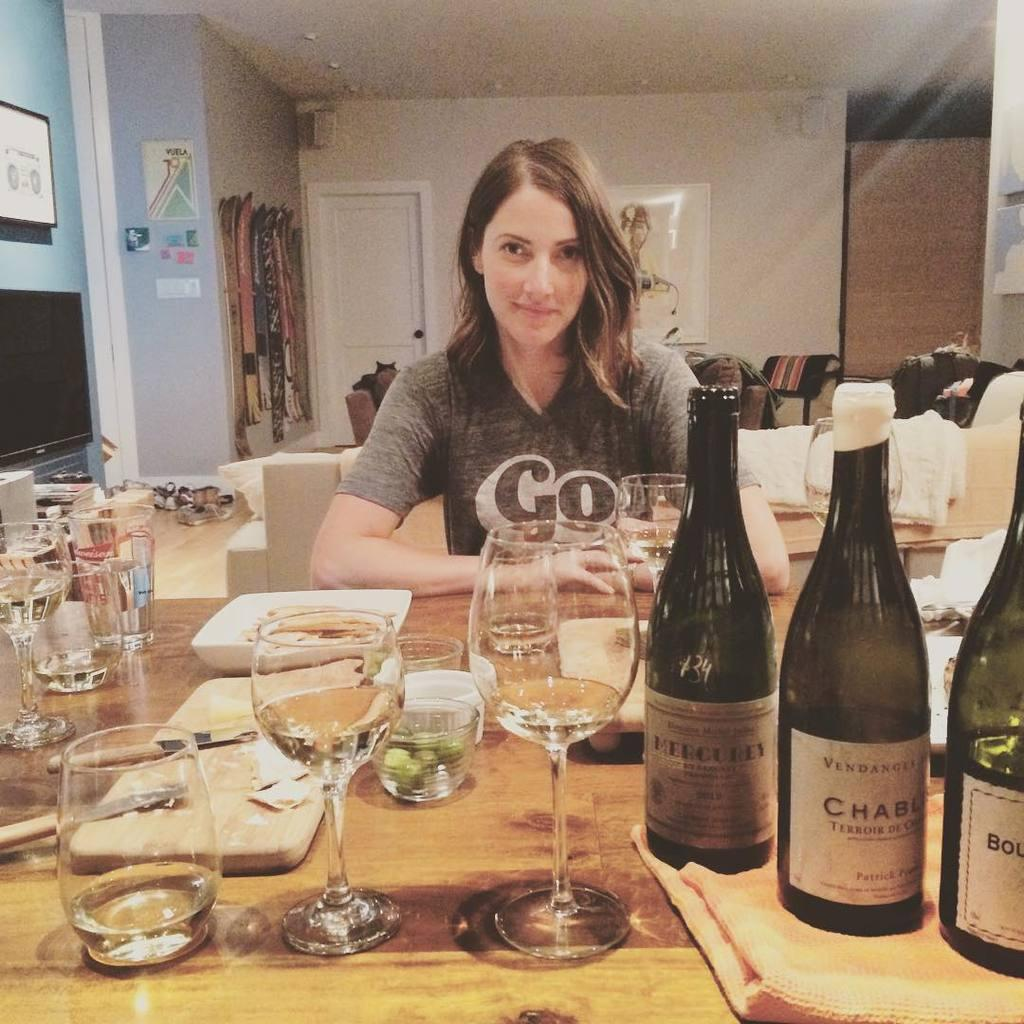Provide a one-sentence caption for the provided image. A woman wearing a t-shirt that says Go sits at a table. 